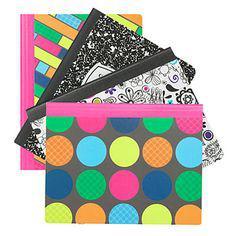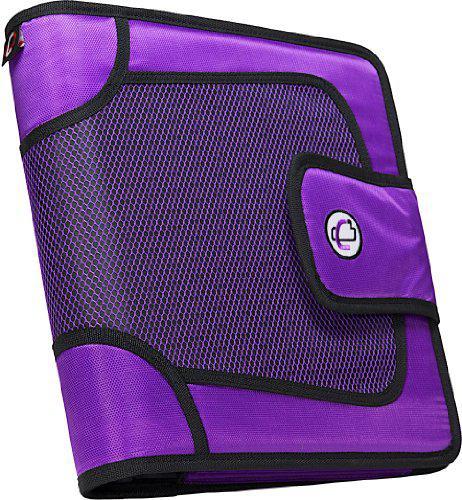The first image is the image on the left, the second image is the image on the right. Assess this claim about the two images: "There are four binders in the image on the right.". Correct or not? Answer yes or no. No. 